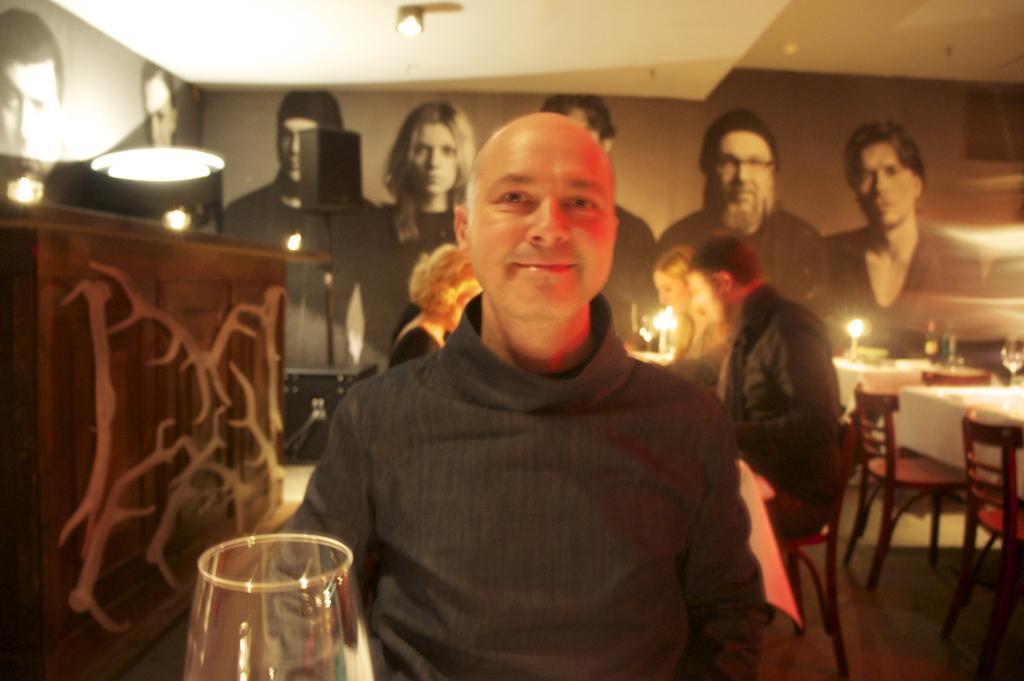How would you summarize this image in a sentence or two? In this image we can see a person. Behind the person there are few persons and a wall. On the wall we can see persons images. At the top we can see the roof and light. On the left side, we can see a table, wall and light. On the right side, we can see chairs, tables and few objects on the table. At the bottom we can see a glass. 